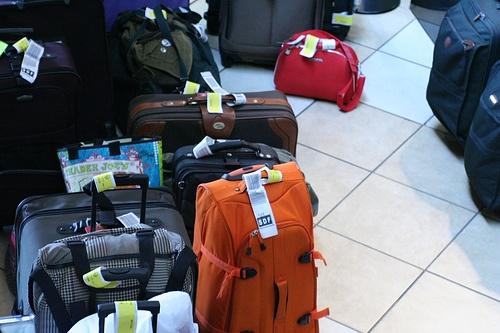Describe the objects in this image and their specific colors. I can see backpack in navy, maroon, brown, and red tones, suitcase in navy, maroon, brown, and red tones, suitcase in navy, black, gray, and darkblue tones, suitcase in navy, black, and gray tones, and suitcase in navy, black, darkgray, and lightblue tones in this image. 